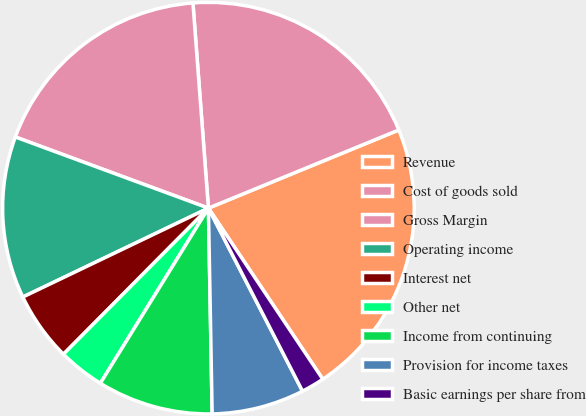Convert chart to OTSL. <chart><loc_0><loc_0><loc_500><loc_500><pie_chart><fcel>Revenue<fcel>Cost of goods sold<fcel>Gross Margin<fcel>Operating income<fcel>Interest net<fcel>Other net<fcel>Income from continuing<fcel>Provision for income taxes<fcel>Basic earnings per share from<nl><fcel>21.82%<fcel>20.0%<fcel>18.18%<fcel>12.73%<fcel>5.45%<fcel>3.64%<fcel>9.09%<fcel>7.27%<fcel>1.82%<nl></chart> 